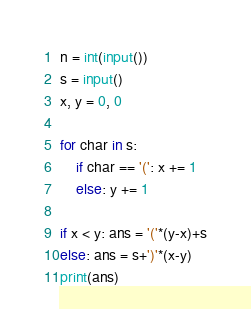<code> <loc_0><loc_0><loc_500><loc_500><_Python_>n = int(input())
s = input()
x, y = 0, 0

for char in s:
    if char == '(': x += 1
    else: y += 1

if x < y: ans = '('*(y-x)+s
else: ans = s+')'*(x-y)
print(ans)</code> 